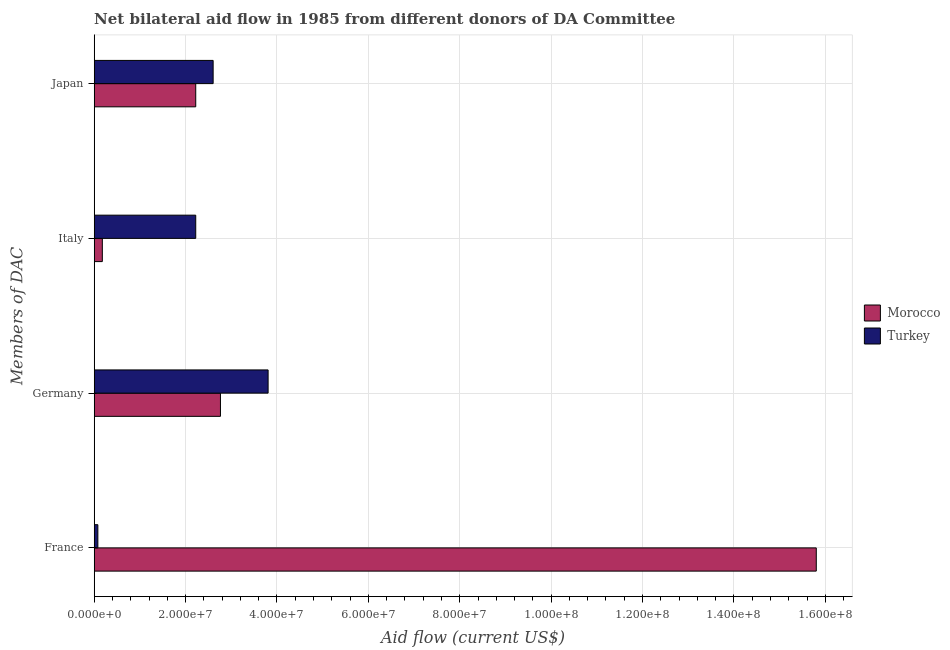How many different coloured bars are there?
Offer a very short reply. 2. Are the number of bars per tick equal to the number of legend labels?
Provide a succinct answer. Yes. Are the number of bars on each tick of the Y-axis equal?
Make the answer very short. Yes. How many bars are there on the 4th tick from the bottom?
Make the answer very short. 2. What is the label of the 2nd group of bars from the top?
Ensure brevity in your answer.  Italy. What is the amount of aid given by germany in Morocco?
Provide a succinct answer. 2.76e+07. Across all countries, what is the maximum amount of aid given by germany?
Offer a terse response. 3.81e+07. Across all countries, what is the minimum amount of aid given by germany?
Your response must be concise. 2.76e+07. In which country was the amount of aid given by germany minimum?
Your answer should be very brief. Morocco. What is the total amount of aid given by japan in the graph?
Provide a succinct answer. 4.82e+07. What is the difference between the amount of aid given by france in Morocco and that in Turkey?
Offer a terse response. 1.57e+08. What is the difference between the amount of aid given by germany in Turkey and the amount of aid given by france in Morocco?
Offer a terse response. -1.20e+08. What is the average amount of aid given by italy per country?
Make the answer very short. 1.20e+07. What is the difference between the amount of aid given by germany and amount of aid given by japan in Morocco?
Provide a succinct answer. 5.41e+06. In how many countries, is the amount of aid given by japan greater than 96000000 US$?
Your response must be concise. 0. What is the ratio of the amount of aid given by france in Morocco to that in Turkey?
Give a very brief answer. 197.54. Is the amount of aid given by italy in Morocco less than that in Turkey?
Your response must be concise. Yes. What is the difference between the highest and the second highest amount of aid given by italy?
Ensure brevity in your answer.  2.04e+07. What is the difference between the highest and the lowest amount of aid given by italy?
Offer a terse response. 2.04e+07. In how many countries, is the amount of aid given by germany greater than the average amount of aid given by germany taken over all countries?
Your answer should be very brief. 1. Is the sum of the amount of aid given by france in Morocco and Turkey greater than the maximum amount of aid given by germany across all countries?
Give a very brief answer. Yes. What does the 2nd bar from the top in Japan represents?
Your response must be concise. Morocco. What does the 1st bar from the bottom in Italy represents?
Make the answer very short. Morocco. Is it the case that in every country, the sum of the amount of aid given by france and amount of aid given by germany is greater than the amount of aid given by italy?
Make the answer very short. Yes. How many bars are there?
Give a very brief answer. 8. Does the graph contain grids?
Offer a very short reply. Yes. Where does the legend appear in the graph?
Make the answer very short. Center right. How many legend labels are there?
Provide a succinct answer. 2. What is the title of the graph?
Offer a terse response. Net bilateral aid flow in 1985 from different donors of DA Committee. Does "Sweden" appear as one of the legend labels in the graph?
Provide a short and direct response. No. What is the label or title of the Y-axis?
Make the answer very short. Members of DAC. What is the Aid flow (current US$) in Morocco in France?
Your response must be concise. 1.58e+08. What is the Aid flow (current US$) of Morocco in Germany?
Ensure brevity in your answer.  2.76e+07. What is the Aid flow (current US$) of Turkey in Germany?
Your response must be concise. 3.81e+07. What is the Aid flow (current US$) in Morocco in Italy?
Your answer should be very brief. 1.78e+06. What is the Aid flow (current US$) in Turkey in Italy?
Your answer should be compact. 2.22e+07. What is the Aid flow (current US$) in Morocco in Japan?
Your answer should be very brief. 2.22e+07. What is the Aid flow (current US$) in Turkey in Japan?
Your response must be concise. 2.60e+07. Across all Members of DAC, what is the maximum Aid flow (current US$) in Morocco?
Give a very brief answer. 1.58e+08. Across all Members of DAC, what is the maximum Aid flow (current US$) in Turkey?
Give a very brief answer. 3.81e+07. Across all Members of DAC, what is the minimum Aid flow (current US$) in Morocco?
Your response must be concise. 1.78e+06. What is the total Aid flow (current US$) in Morocco in the graph?
Keep it short and to the point. 2.10e+08. What is the total Aid flow (current US$) of Turkey in the graph?
Make the answer very short. 8.71e+07. What is the difference between the Aid flow (current US$) of Morocco in France and that in Germany?
Provide a short and direct response. 1.30e+08. What is the difference between the Aid flow (current US$) in Turkey in France and that in Germany?
Offer a terse response. -3.73e+07. What is the difference between the Aid flow (current US$) of Morocco in France and that in Italy?
Give a very brief answer. 1.56e+08. What is the difference between the Aid flow (current US$) of Turkey in France and that in Italy?
Offer a very short reply. -2.14e+07. What is the difference between the Aid flow (current US$) in Morocco in France and that in Japan?
Your answer should be very brief. 1.36e+08. What is the difference between the Aid flow (current US$) in Turkey in France and that in Japan?
Provide a short and direct response. -2.52e+07. What is the difference between the Aid flow (current US$) in Morocco in Germany and that in Italy?
Ensure brevity in your answer.  2.58e+07. What is the difference between the Aid flow (current US$) in Turkey in Germany and that in Italy?
Offer a terse response. 1.58e+07. What is the difference between the Aid flow (current US$) of Morocco in Germany and that in Japan?
Keep it short and to the point. 5.41e+06. What is the difference between the Aid flow (current US$) of Turkey in Germany and that in Japan?
Keep it short and to the point. 1.20e+07. What is the difference between the Aid flow (current US$) of Morocco in Italy and that in Japan?
Offer a very short reply. -2.04e+07. What is the difference between the Aid flow (current US$) in Turkey in Italy and that in Japan?
Offer a very short reply. -3.81e+06. What is the difference between the Aid flow (current US$) in Morocco in France and the Aid flow (current US$) in Turkey in Germany?
Your answer should be very brief. 1.20e+08. What is the difference between the Aid flow (current US$) in Morocco in France and the Aid flow (current US$) in Turkey in Italy?
Provide a short and direct response. 1.36e+08. What is the difference between the Aid flow (current US$) of Morocco in France and the Aid flow (current US$) of Turkey in Japan?
Give a very brief answer. 1.32e+08. What is the difference between the Aid flow (current US$) in Morocco in Germany and the Aid flow (current US$) in Turkey in Italy?
Ensure brevity in your answer.  5.41e+06. What is the difference between the Aid flow (current US$) in Morocco in Germany and the Aid flow (current US$) in Turkey in Japan?
Your response must be concise. 1.60e+06. What is the difference between the Aid flow (current US$) in Morocco in Italy and the Aid flow (current US$) in Turkey in Japan?
Your response must be concise. -2.42e+07. What is the average Aid flow (current US$) in Morocco per Members of DAC?
Provide a succinct answer. 5.24e+07. What is the average Aid flow (current US$) in Turkey per Members of DAC?
Make the answer very short. 2.18e+07. What is the difference between the Aid flow (current US$) in Morocco and Aid flow (current US$) in Turkey in France?
Offer a terse response. 1.57e+08. What is the difference between the Aid flow (current US$) of Morocco and Aid flow (current US$) of Turkey in Germany?
Give a very brief answer. -1.04e+07. What is the difference between the Aid flow (current US$) in Morocco and Aid flow (current US$) in Turkey in Italy?
Offer a terse response. -2.04e+07. What is the difference between the Aid flow (current US$) in Morocco and Aid flow (current US$) in Turkey in Japan?
Your response must be concise. -3.81e+06. What is the ratio of the Aid flow (current US$) of Morocco in France to that in Germany?
Keep it short and to the point. 5.72. What is the ratio of the Aid flow (current US$) in Turkey in France to that in Germany?
Your answer should be very brief. 0.02. What is the ratio of the Aid flow (current US$) in Morocco in France to that in Italy?
Offer a terse response. 88.78. What is the ratio of the Aid flow (current US$) in Turkey in France to that in Italy?
Give a very brief answer. 0.04. What is the ratio of the Aid flow (current US$) in Morocco in France to that in Japan?
Make the answer very short. 7.11. What is the ratio of the Aid flow (current US$) in Turkey in France to that in Japan?
Provide a short and direct response. 0.03. What is the ratio of the Aid flow (current US$) of Morocco in Germany to that in Italy?
Provide a short and direct response. 15.52. What is the ratio of the Aid flow (current US$) in Turkey in Germany to that in Italy?
Provide a succinct answer. 1.71. What is the ratio of the Aid flow (current US$) of Morocco in Germany to that in Japan?
Your answer should be very brief. 1.24. What is the ratio of the Aid flow (current US$) in Turkey in Germany to that in Japan?
Ensure brevity in your answer.  1.46. What is the ratio of the Aid flow (current US$) in Morocco in Italy to that in Japan?
Offer a terse response. 0.08. What is the ratio of the Aid flow (current US$) of Turkey in Italy to that in Japan?
Provide a short and direct response. 0.85. What is the difference between the highest and the second highest Aid flow (current US$) in Morocco?
Provide a short and direct response. 1.30e+08. What is the difference between the highest and the second highest Aid flow (current US$) of Turkey?
Provide a short and direct response. 1.20e+07. What is the difference between the highest and the lowest Aid flow (current US$) in Morocco?
Offer a terse response. 1.56e+08. What is the difference between the highest and the lowest Aid flow (current US$) in Turkey?
Make the answer very short. 3.73e+07. 